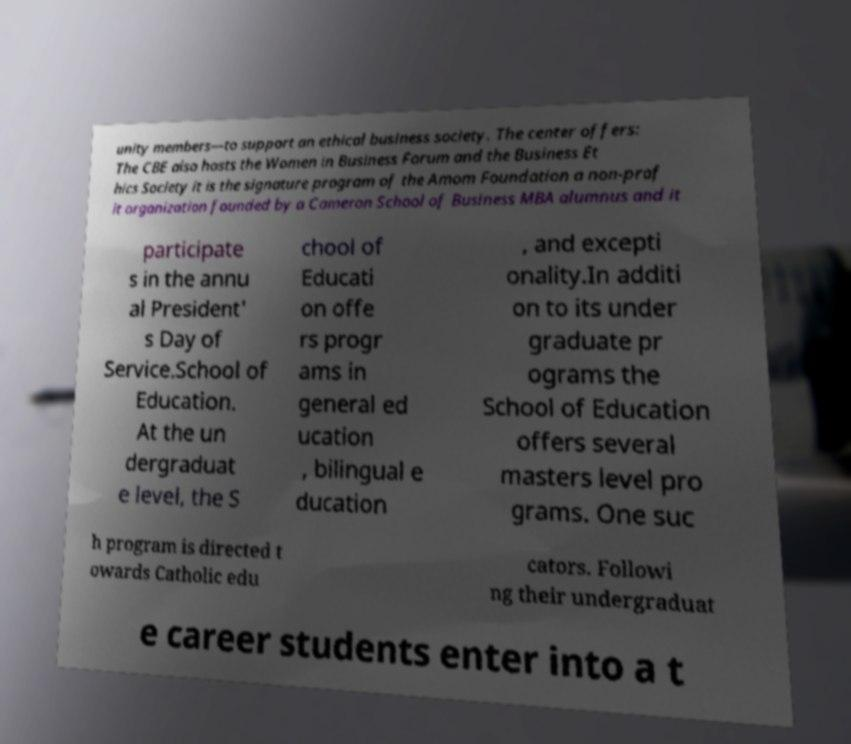There's text embedded in this image that I need extracted. Can you transcribe it verbatim? unity members—to support an ethical business society. The center offers: The CBE also hosts the Women in Business Forum and the Business Et hics Society it is the signature program of the Amom Foundation a non-prof it organization founded by a Cameron School of Business MBA alumnus and it participate s in the annu al President' s Day of Service.School of Education. At the un dergraduat e level, the S chool of Educati on offe rs progr ams in general ed ucation , bilingual e ducation , and excepti onality.In additi on to its under graduate pr ograms the School of Education offers several masters level pro grams. One suc h program is directed t owards Catholic edu cators. Followi ng their undergraduat e career students enter into a t 